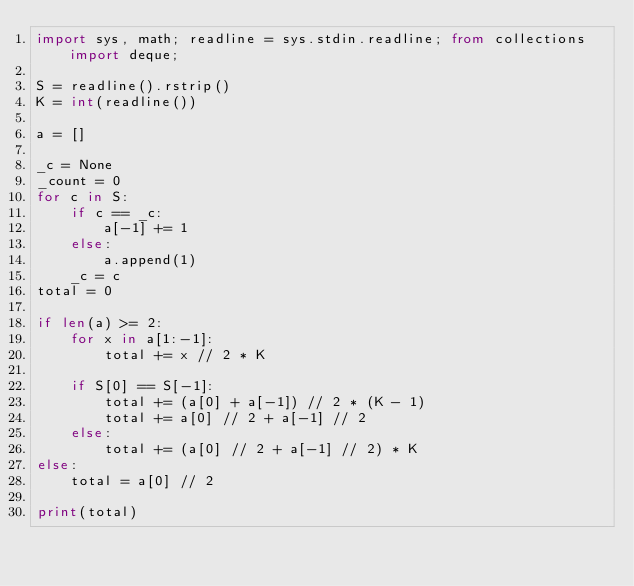<code> <loc_0><loc_0><loc_500><loc_500><_Python_>import sys, math; readline = sys.stdin.readline; from collections import deque;

S = readline().rstrip()
K = int(readline())

a = []

_c = None
_count = 0
for c in S:
    if c == _c:
        a[-1] += 1
    else:
        a.append(1)
    _c = c
total = 0

if len(a) >= 2:
    for x in a[1:-1]:
        total += x // 2 * K

    if S[0] == S[-1]:
        total += (a[0] + a[-1]) // 2 * (K - 1)
        total += a[0] // 2 + a[-1] // 2
    else:
        total += (a[0] // 2 + a[-1] // 2) * K
else:
    total = a[0] // 2

print(total)</code> 